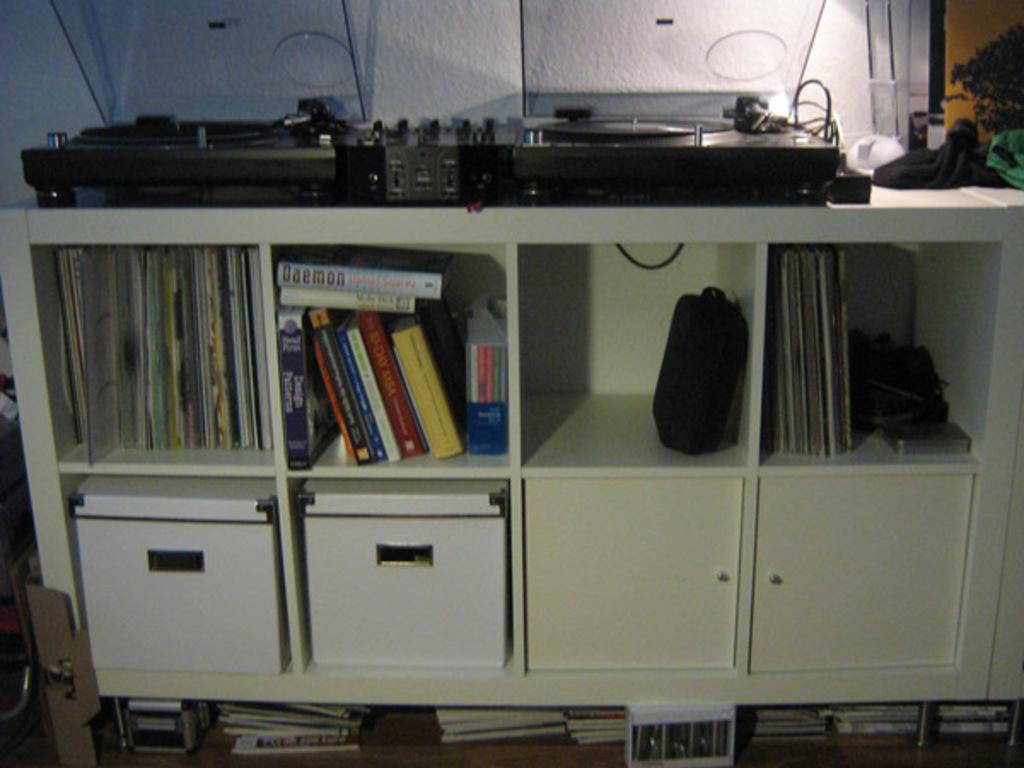Please provide a concise description of this image. In this picture we can see books on shelves, boxes, devices, wall and some objects. 